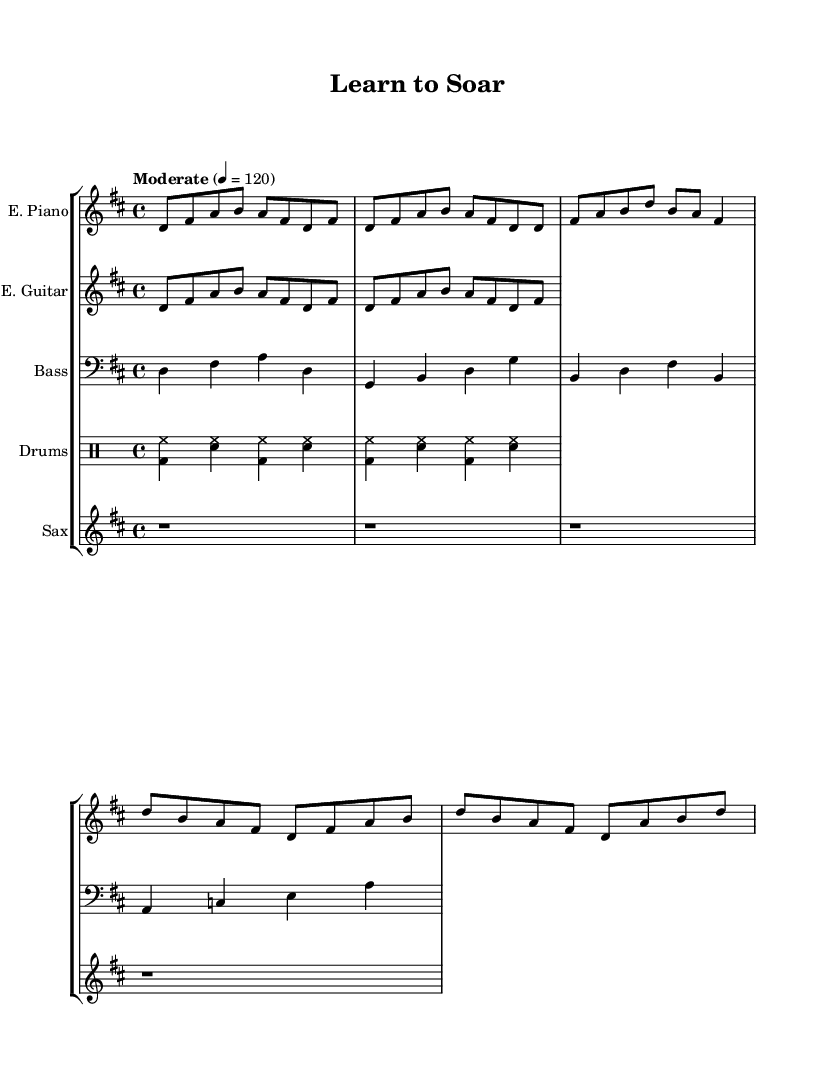What is the key signature of this music? The key signature is identified by the sharps or flats placed at the beginning of the staff. In this case, there are two sharps, which indicates D major.
Answer: D major What is the time signature of this music? The time signature is found at the beginning of the staff, represented by two numbers. Here, it is 4 over 4, indicating four beats per measure.
Answer: 4/4 What is the tempo marking for this piece? The tempo marking is located above the staff, providing the speed of the music. It states "Moderate" with a metronome marking of quarter note equals 120 beats per minute.
Answer: Moderate How many measures are in the verse section? The verse section, indicated by the lyrics, consists of the first four lines. Counting the measures that contain lyrics, we find a total of three measures.
Answer: 3 What instruments are included in this score? By examining the staff group, we can identify the specific instruments listed, which are Electric Piano, Electric Guitar, Bass, Drums, and Saxophone.
Answer: Electric Piano, Electric Guitar, Bass, Drums, Saxophone What is the primary theme conveyed in the chorus lyrics? The chorus discusses themes of aspiration and the value of education, emphasizing reaching for the stars and believing in oneself, which aligns with motivational messaging.
Answer: Aspiration and education What style of music does this composition represent? By looking at the combination of instruments and the rhythmic style presented, we can conclude that this piece harmonizes elements of jazz and rock, defining it as jazz-rock fusion.
Answer: Jazz-rock fusion 